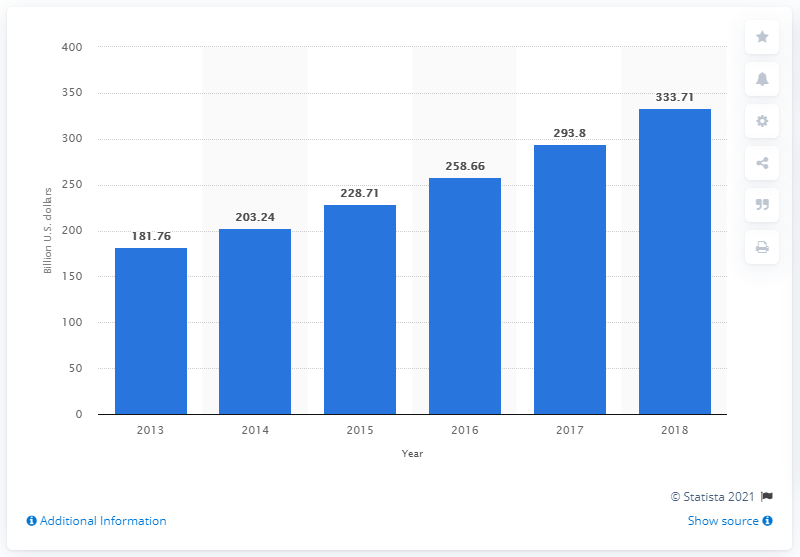Give some essential details in this illustration. In 2013, Pakistan's total consumer spending was 181.76. 